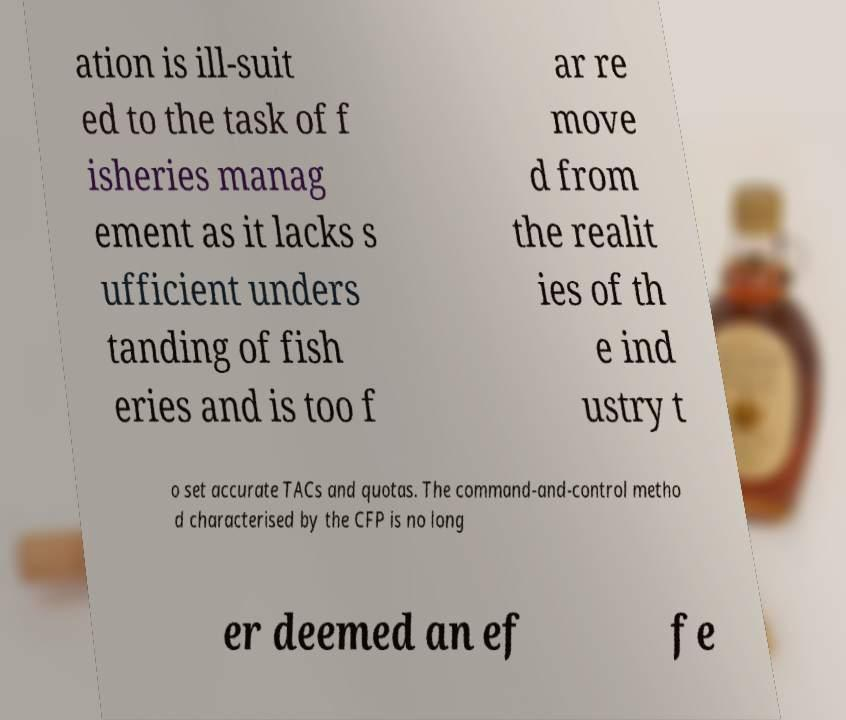For documentation purposes, I need the text within this image transcribed. Could you provide that? ation is ill-suit ed to the task of f isheries manag ement as it lacks s ufficient unders tanding of fish eries and is too f ar re move d from the realit ies of th e ind ustry t o set accurate TACs and quotas. The command-and-control metho d characterised by the CFP is no long er deemed an ef fe 